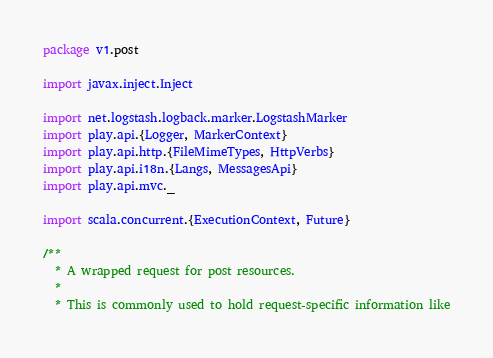Convert code to text. <code><loc_0><loc_0><loc_500><loc_500><_Scala_>package v1.post

import javax.inject.Inject

import net.logstash.logback.marker.LogstashMarker
import play.api.{Logger, MarkerContext}
import play.api.http.{FileMimeTypes, HttpVerbs}
import play.api.i18n.{Langs, MessagesApi}
import play.api.mvc._

import scala.concurrent.{ExecutionContext, Future}

/**
  * A wrapped request for post resources.
  *
  * This is commonly used to hold request-specific information like</code> 